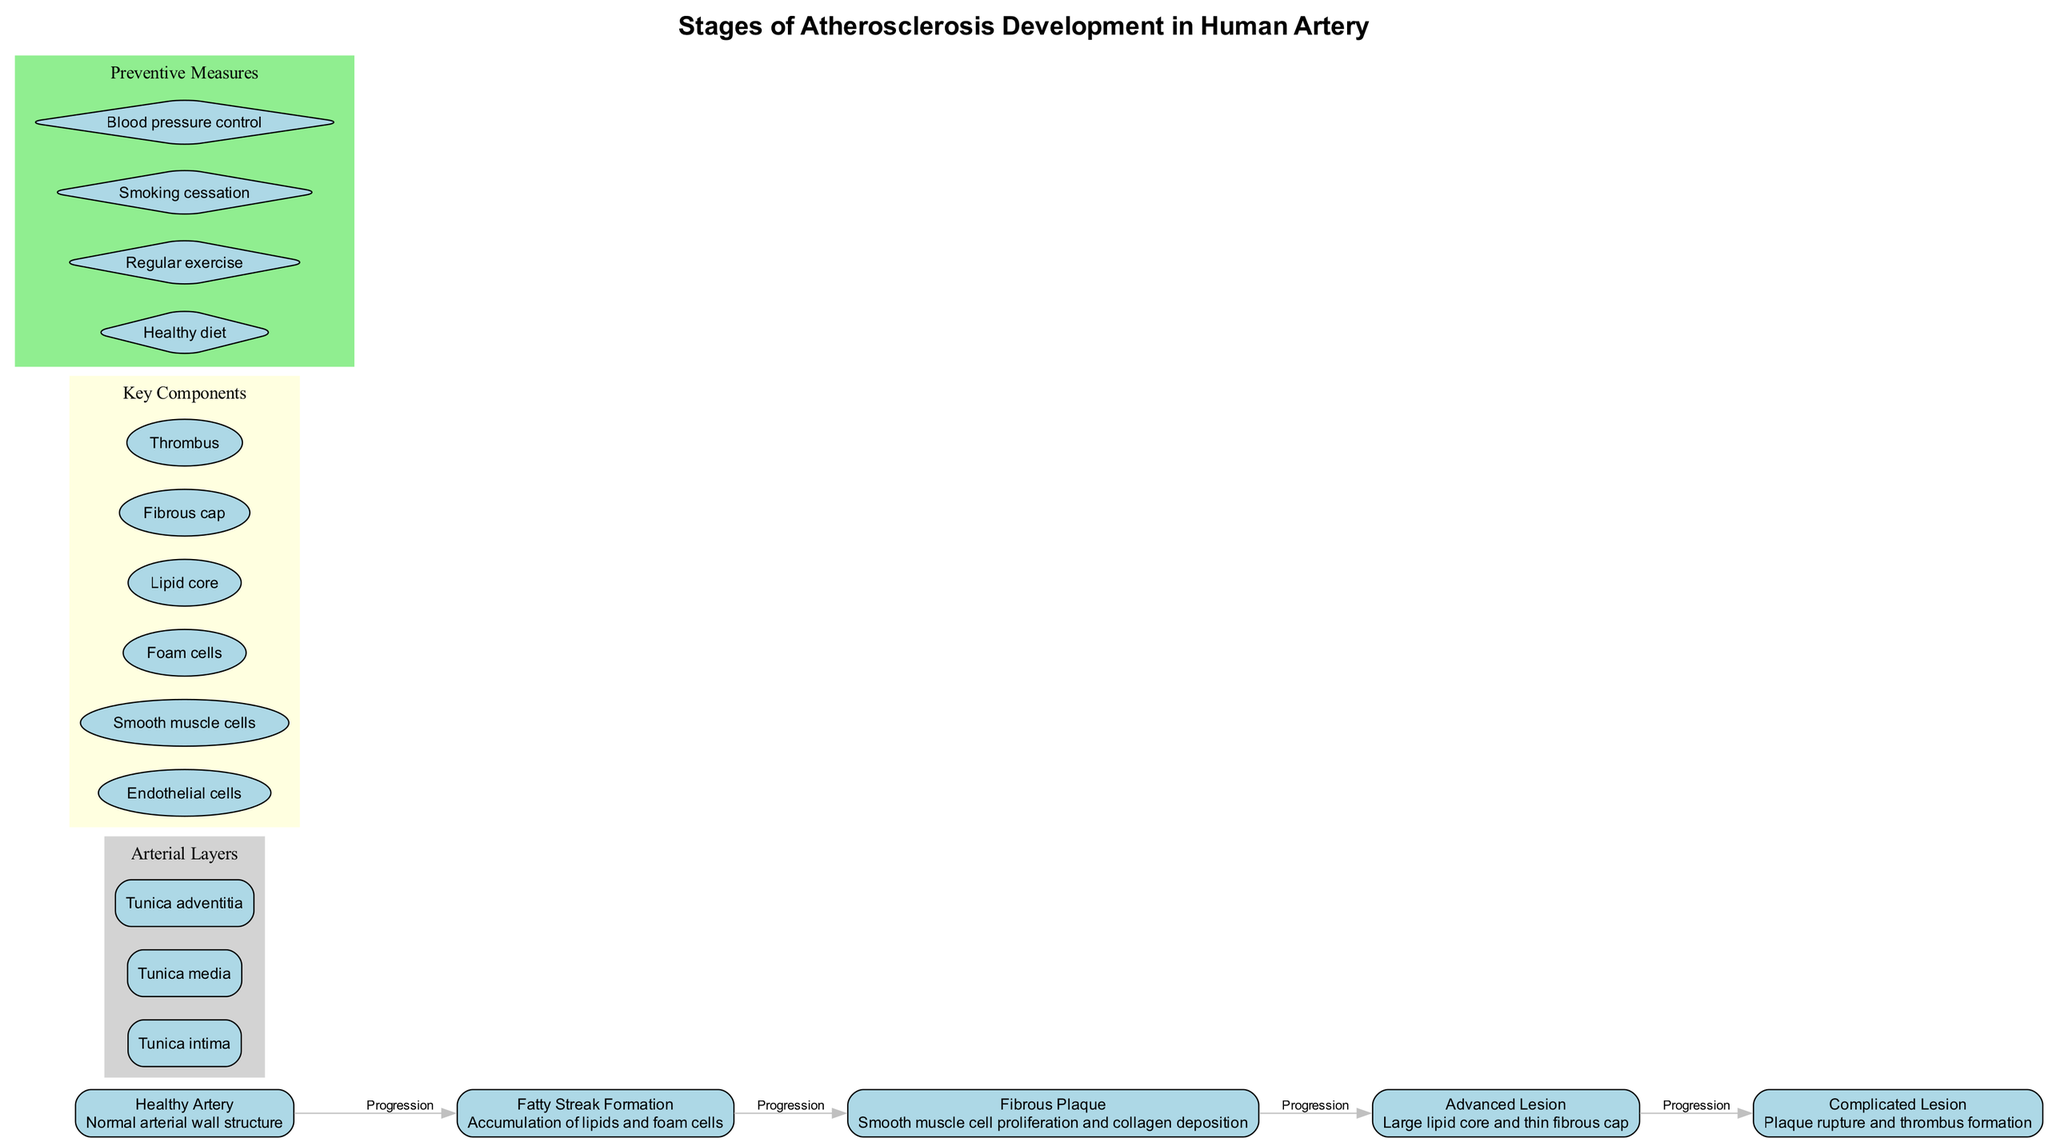What is the first stage of atherosclerosis? The first node in the diagram represents the initial stage of atherosclerosis, which is labeled "Healthy Artery," indicating that this is the normal condition before any disease progresses.
Answer: Healthy Artery How many stages of atherosclerosis are illustrated in the diagram? By counting the number of nodes in the main progression of stages, there are five distinct stages listed from "Healthy Artery" to "Complicated Lesion."
Answer: 5 What is present in the "Fatty Streak Formation" stage? Referring to the description associated with the second stage, it states that it consists of "Accumulation of lipids and foam cells," which indicates the specific components present at this stage.
Answer: Lipids and foam cells What kind of cells proliferate in the "Fibrous Plaque" stage? The description for the third stage specifies "Smooth muscle cell proliferation," which directly identifies the cell type that increases during this stage of atherosclerosis.
Answer: Smooth muscle cells What component is crucial for the formation of a thrombus in the last stage? Analyzing the description of the "Complicated Lesion," it highlights "Plaque rupture and thrombus formation," which implies that the thrombus is a critical component of this stage, indicating its formation is a reactive process to the plaque rupture.
Answer: Thrombus Which layer of the artery is indicated as the outermost layer? The subgraph representing arterial layers will typically be arranged from innermost to outermost, with "Tunica adventitia" labeled as the outermost layer of the artery structure.
Answer: Tunica adventitia What is the primary preventive measure to manage atherosclerosis? The section on preventive measures lists several actions, but "Healthy diet" is often considered the most important and fundamental approach in managing cardiovascular health and preventing atherosclerosis.
Answer: Healthy diet In which stage do you find a "large lipid core"? The description for the "Advanced Lesion" specifies the presence of "Large lipid core," making it clear that this characteristic is specific to this later stage of atherosclerosis development.
Answer: Advanced Lesion What color represents the key components in the diagram? Observing the subgraph labeled as "Key Components," it's noted that the components are filled with "lightyellow," which indicates the specific color used to represent these crucial elements visually.
Answer: Light yellow 